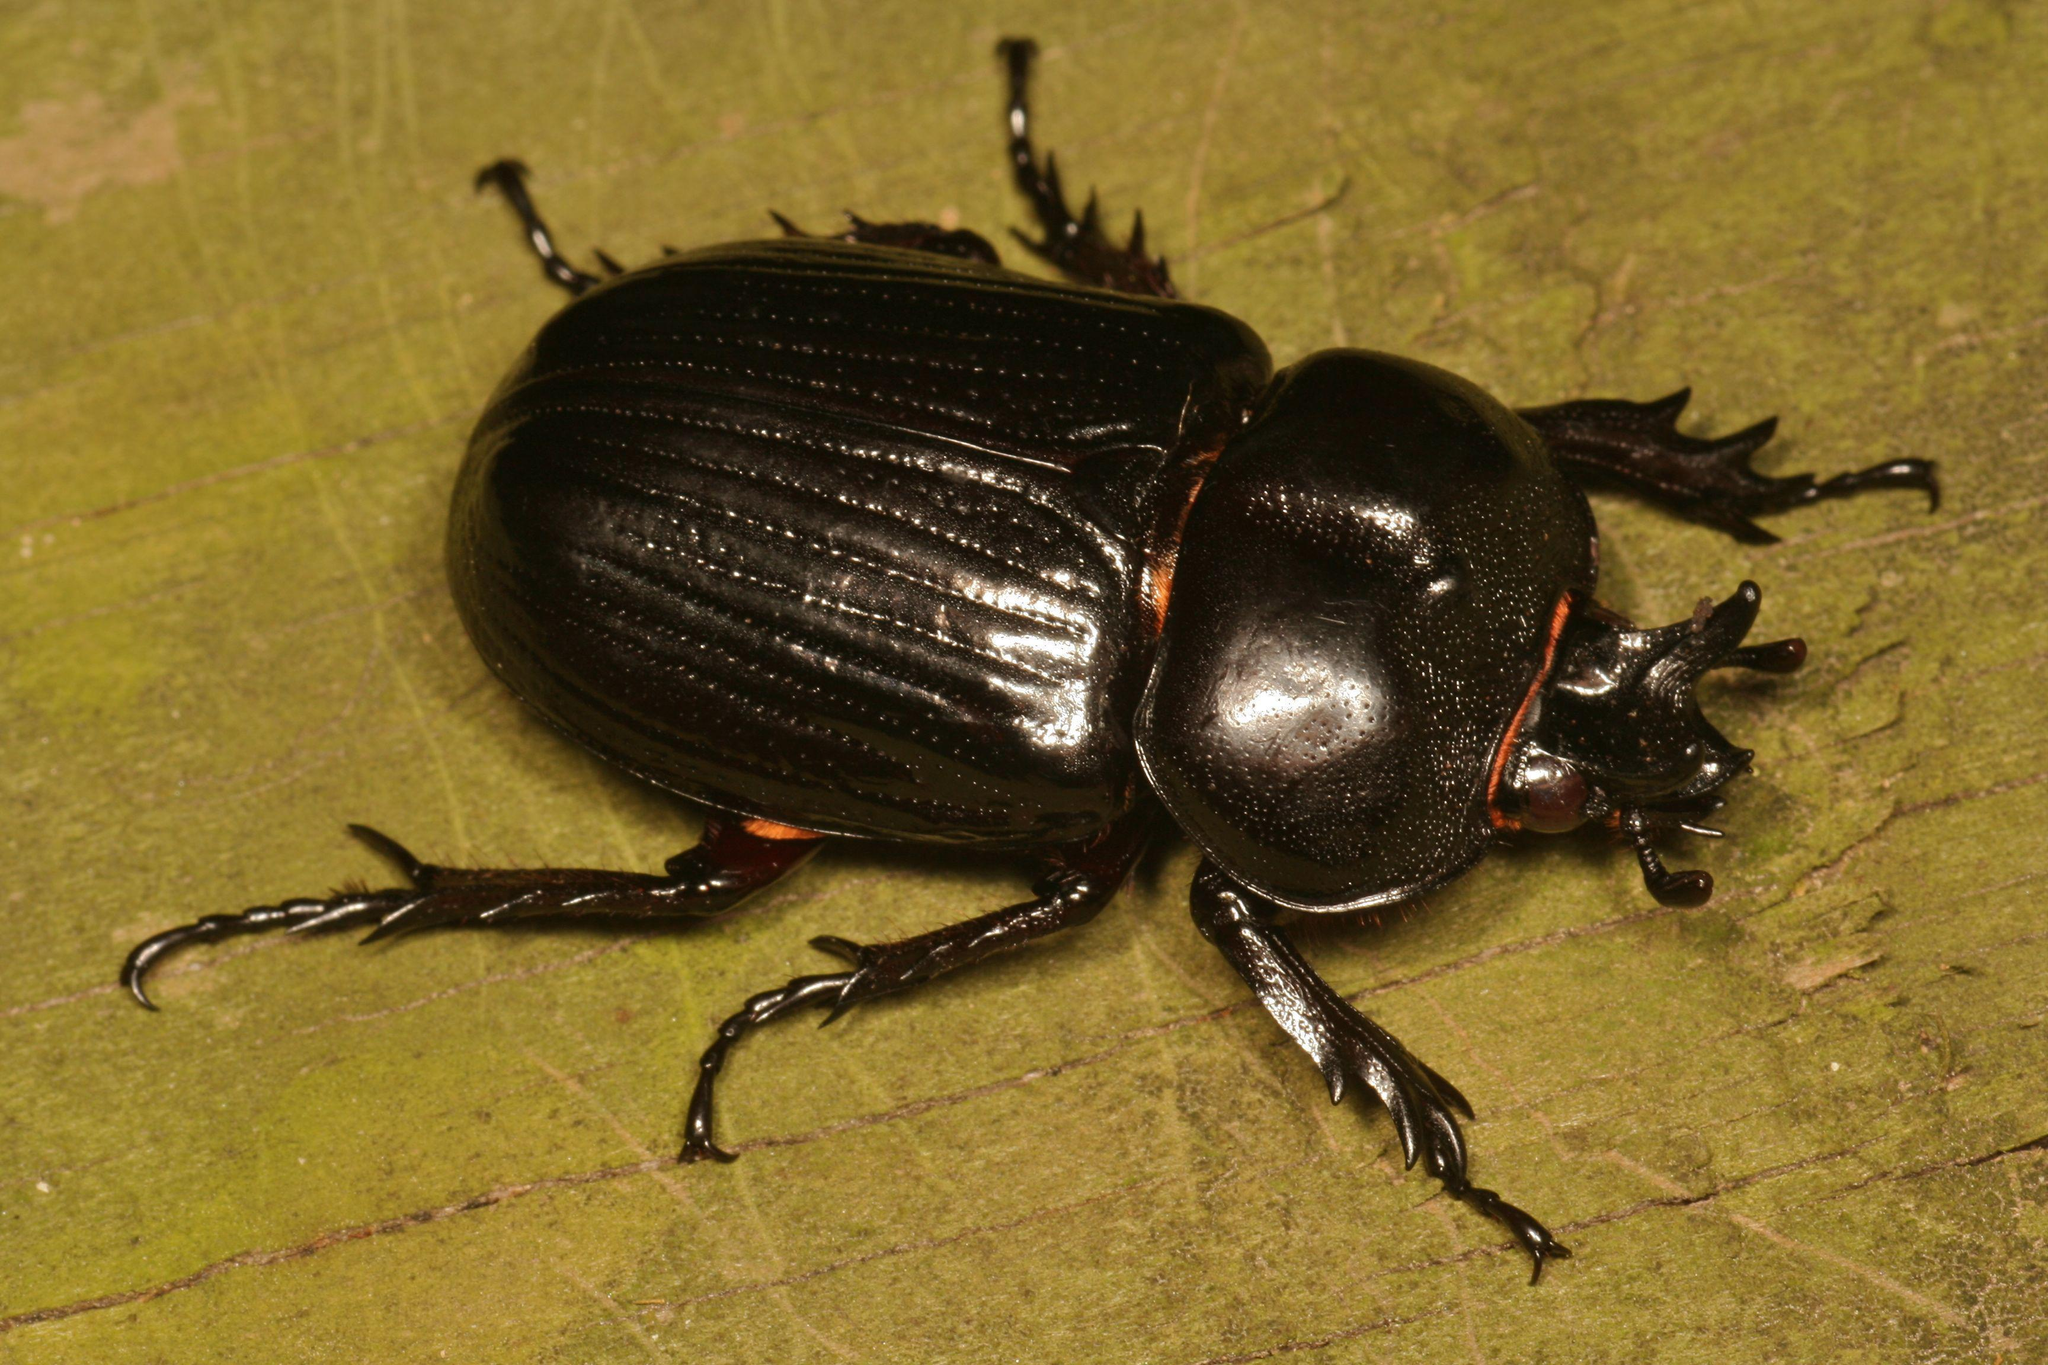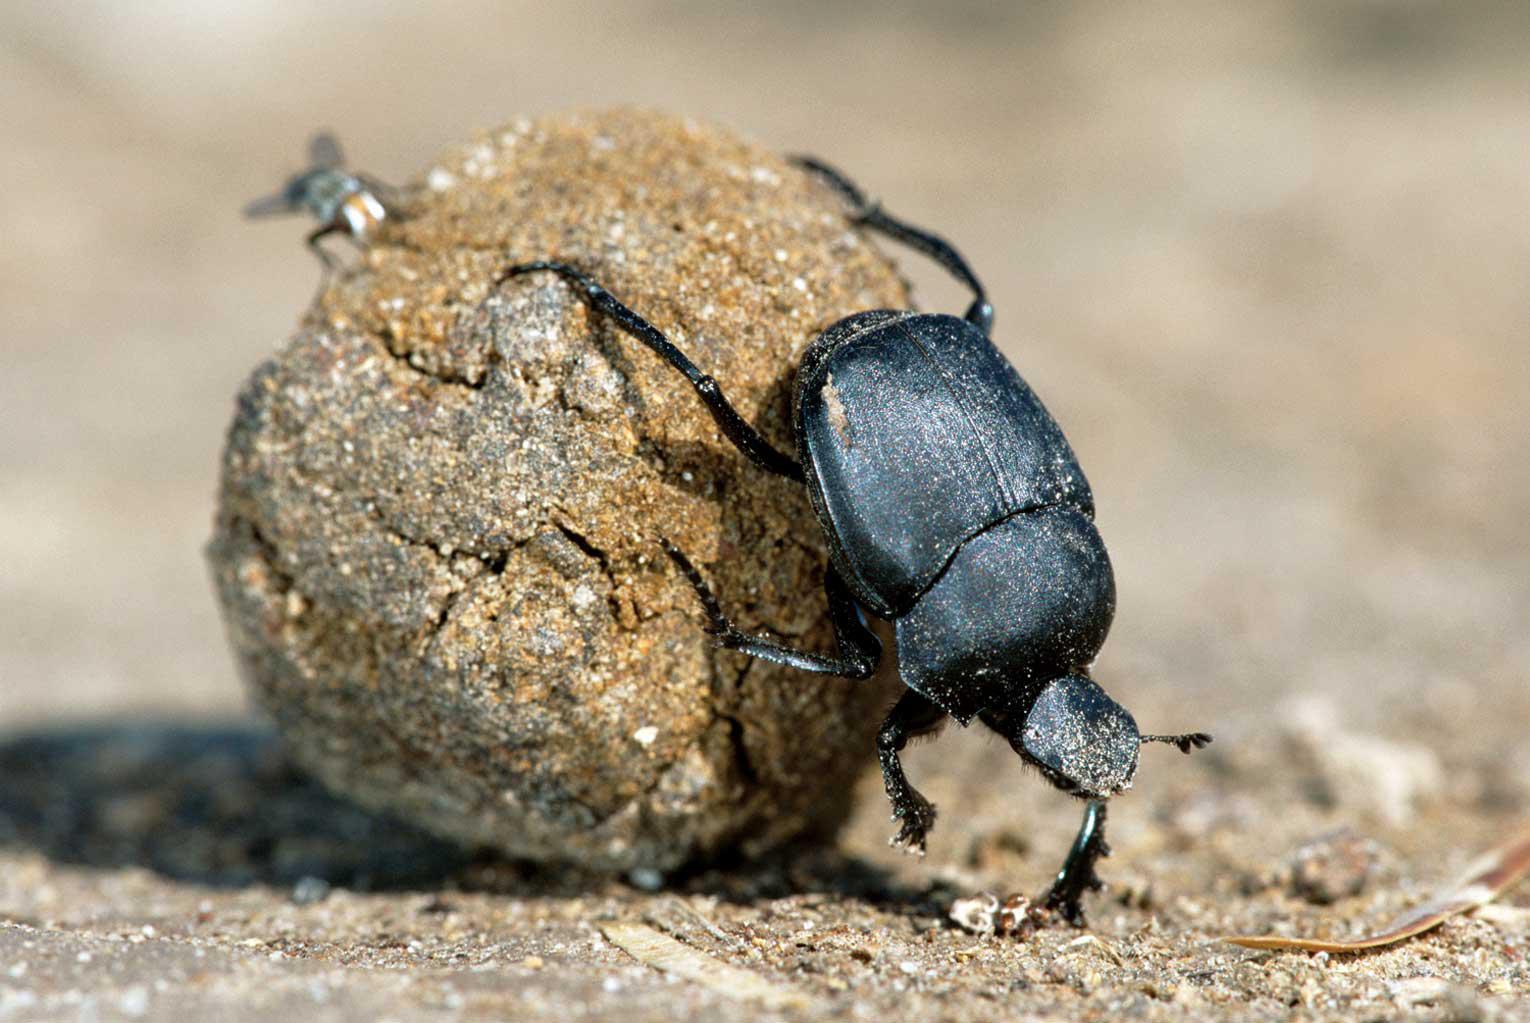The first image is the image on the left, the second image is the image on the right. Assess this claim about the two images: "there is a ball of dung in the right pic". Correct or not? Answer yes or no. Yes. The first image is the image on the left, the second image is the image on the right. Considering the images on both sides, is "A beetle is pictured with a ball of dug." valid? Answer yes or no. Yes. 